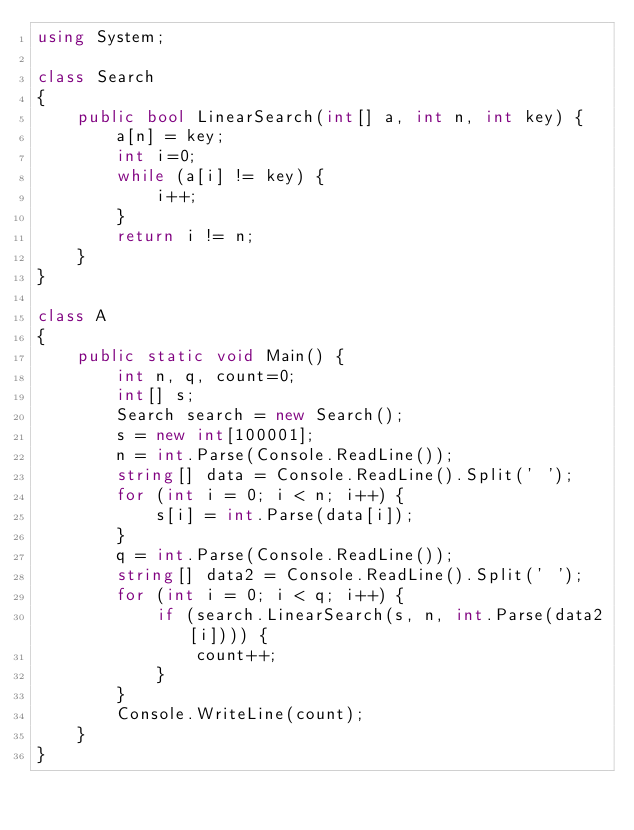<code> <loc_0><loc_0><loc_500><loc_500><_C#_>using System;

class Search
{
    public bool LinearSearch(int[] a, int n, int key) {
        a[n] = key;
        int i=0;
        while (a[i] != key) {
            i++;
        }
        return i != n;
    }
}

class A
{
    public static void Main() {
        int n, q, count=0;
        int[] s;
        Search search = new Search();
        s = new int[100001];
        n = int.Parse(Console.ReadLine());
        string[] data = Console.ReadLine().Split(' '); 
        for (int i = 0; i < n; i++) {
            s[i] = int.Parse(data[i]);
        }
        q = int.Parse(Console.ReadLine());
        string[] data2 = Console.ReadLine().Split(' ');
        for (int i = 0; i < q; i++) {
            if (search.LinearSearch(s, n, int.Parse(data2[i]))) {
                count++;
            }
        }
        Console.WriteLine(count);
    }
}
</code> 